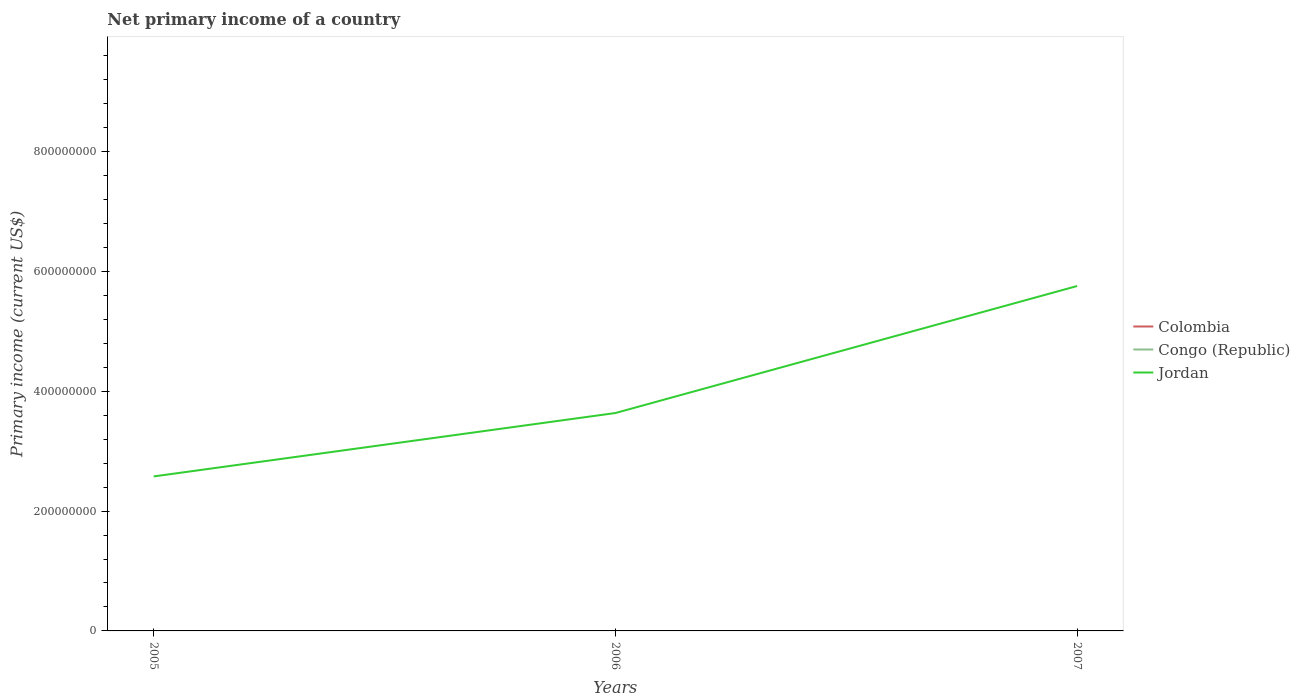Is the number of lines equal to the number of legend labels?
Give a very brief answer. No. Across all years, what is the maximum primary income in Jordan?
Your response must be concise. 2.58e+08. What is the total primary income in Jordan in the graph?
Make the answer very short. -3.18e+08. What is the difference between the highest and the second highest primary income in Jordan?
Offer a terse response. 3.18e+08. What is the difference between the highest and the lowest primary income in Congo (Republic)?
Keep it short and to the point. 0. Does the graph contain any zero values?
Your response must be concise. Yes. Where does the legend appear in the graph?
Give a very brief answer. Center right. How many legend labels are there?
Provide a short and direct response. 3. How are the legend labels stacked?
Ensure brevity in your answer.  Vertical. What is the title of the graph?
Keep it short and to the point. Net primary income of a country. Does "Yemen, Rep." appear as one of the legend labels in the graph?
Your response must be concise. No. What is the label or title of the X-axis?
Keep it short and to the point. Years. What is the label or title of the Y-axis?
Your answer should be compact. Primary income (current US$). What is the Primary income (current US$) in Jordan in 2005?
Your response must be concise. 2.58e+08. What is the Primary income (current US$) in Congo (Republic) in 2006?
Offer a very short reply. 0. What is the Primary income (current US$) of Jordan in 2006?
Give a very brief answer. 3.64e+08. What is the Primary income (current US$) of Colombia in 2007?
Provide a short and direct response. 0. What is the Primary income (current US$) in Congo (Republic) in 2007?
Give a very brief answer. 0. What is the Primary income (current US$) in Jordan in 2007?
Ensure brevity in your answer.  5.76e+08. Across all years, what is the maximum Primary income (current US$) of Jordan?
Give a very brief answer. 5.76e+08. Across all years, what is the minimum Primary income (current US$) of Jordan?
Your answer should be very brief. 2.58e+08. What is the total Primary income (current US$) in Congo (Republic) in the graph?
Give a very brief answer. 0. What is the total Primary income (current US$) in Jordan in the graph?
Provide a succinct answer. 1.20e+09. What is the difference between the Primary income (current US$) of Jordan in 2005 and that in 2006?
Keep it short and to the point. -1.06e+08. What is the difference between the Primary income (current US$) of Jordan in 2005 and that in 2007?
Provide a short and direct response. -3.18e+08. What is the difference between the Primary income (current US$) in Jordan in 2006 and that in 2007?
Your answer should be very brief. -2.12e+08. What is the average Primary income (current US$) of Congo (Republic) per year?
Give a very brief answer. 0. What is the average Primary income (current US$) of Jordan per year?
Your answer should be very brief. 3.99e+08. What is the ratio of the Primary income (current US$) of Jordan in 2005 to that in 2006?
Provide a short and direct response. 0.71. What is the ratio of the Primary income (current US$) of Jordan in 2005 to that in 2007?
Provide a short and direct response. 0.45. What is the ratio of the Primary income (current US$) in Jordan in 2006 to that in 2007?
Keep it short and to the point. 0.63. What is the difference between the highest and the second highest Primary income (current US$) in Jordan?
Ensure brevity in your answer.  2.12e+08. What is the difference between the highest and the lowest Primary income (current US$) in Jordan?
Keep it short and to the point. 3.18e+08. 